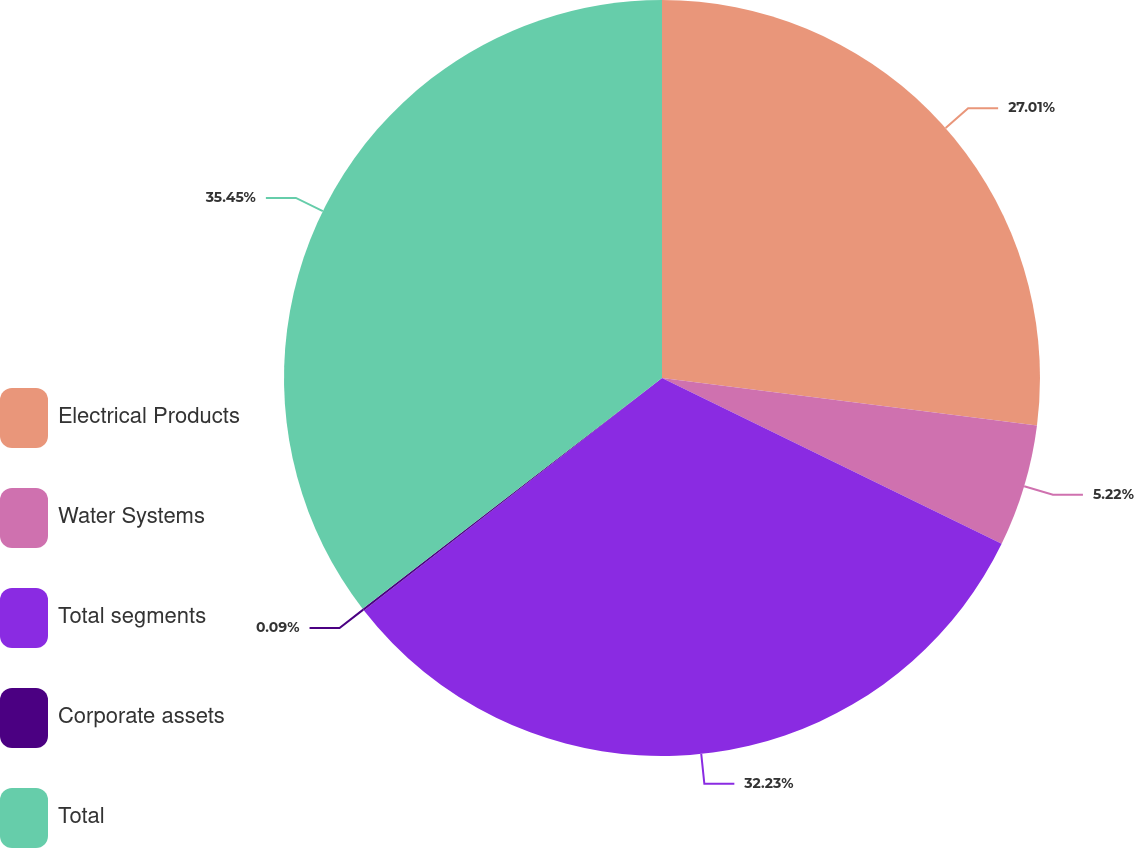Convert chart to OTSL. <chart><loc_0><loc_0><loc_500><loc_500><pie_chart><fcel>Electrical Products<fcel>Water Systems<fcel>Total segments<fcel>Corporate assets<fcel>Total<nl><fcel>27.01%<fcel>5.22%<fcel>32.23%<fcel>0.09%<fcel>35.45%<nl></chart> 